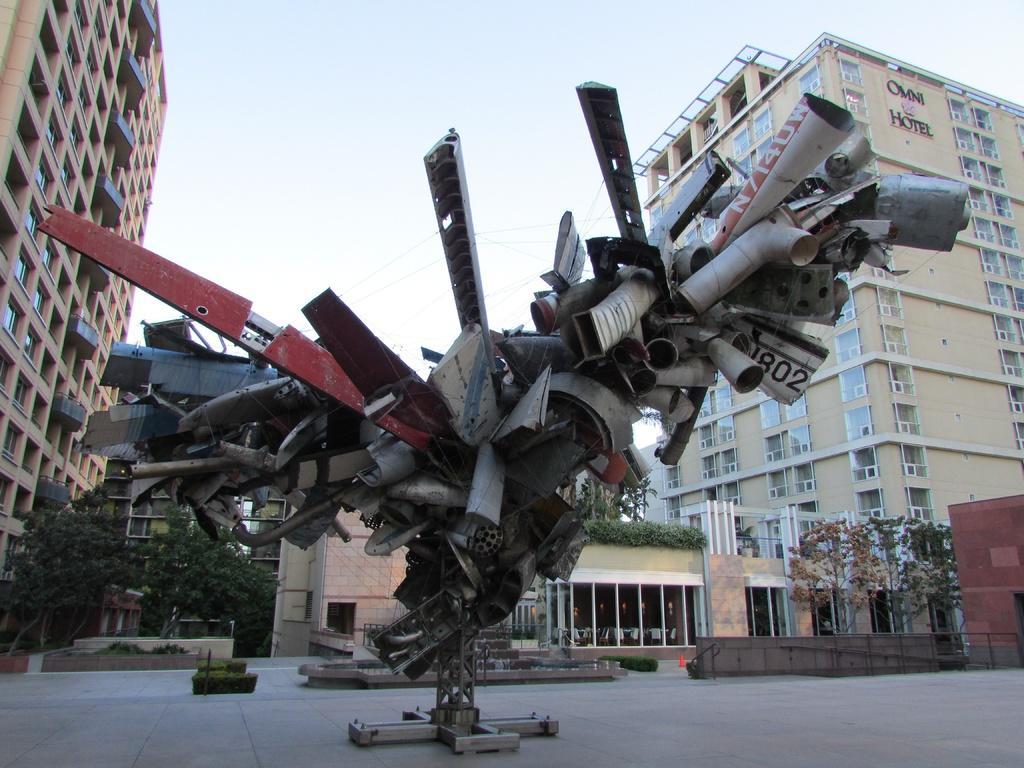In one or two sentences, can you explain what this image depicts? In this image in the front there are metal objects. In the background there are buildings and trees. 